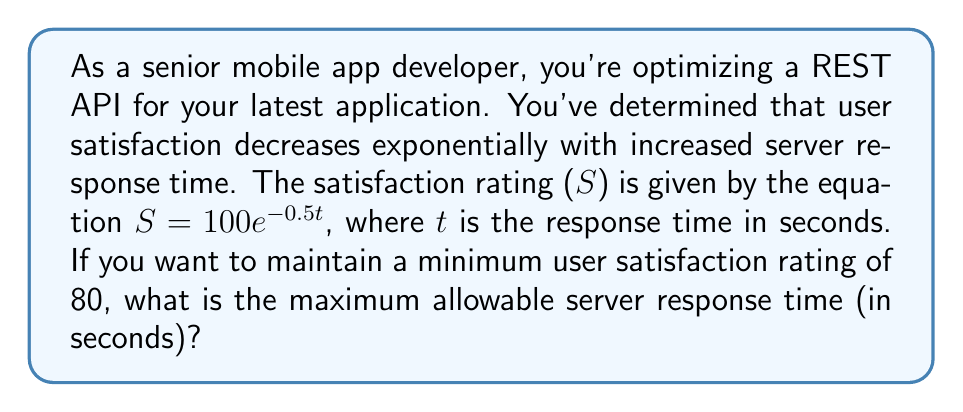Give your solution to this math problem. To solve this problem, we need to use the given exponential equation and solve for t when S = 80.

1. Start with the given equation:
   $S = 100e^{-0.5t}$

2. Substitute S = 80:
   $80 = 100e^{-0.5t}$

3. Divide both sides by 100:
   $0.8 = e^{-0.5t}$

4. Take the natural logarithm of both sides:
   $\ln(0.8) = \ln(e^{-0.5t})$

5. Simplify the right side using the properties of logarithms:
   $\ln(0.8) = -0.5t$

6. Divide both sides by -0.5:
   $\frac{\ln(0.8)}{-0.5} = t$

7. Calculate the value:
   $t \approx 0.4463$ seconds

Therefore, the maximum allowable server response time to maintain a minimum user satisfaction rating of 80 is approximately 0.4463 seconds.
Answer: The maximum allowable server response time is approximately 0.4463 seconds. 